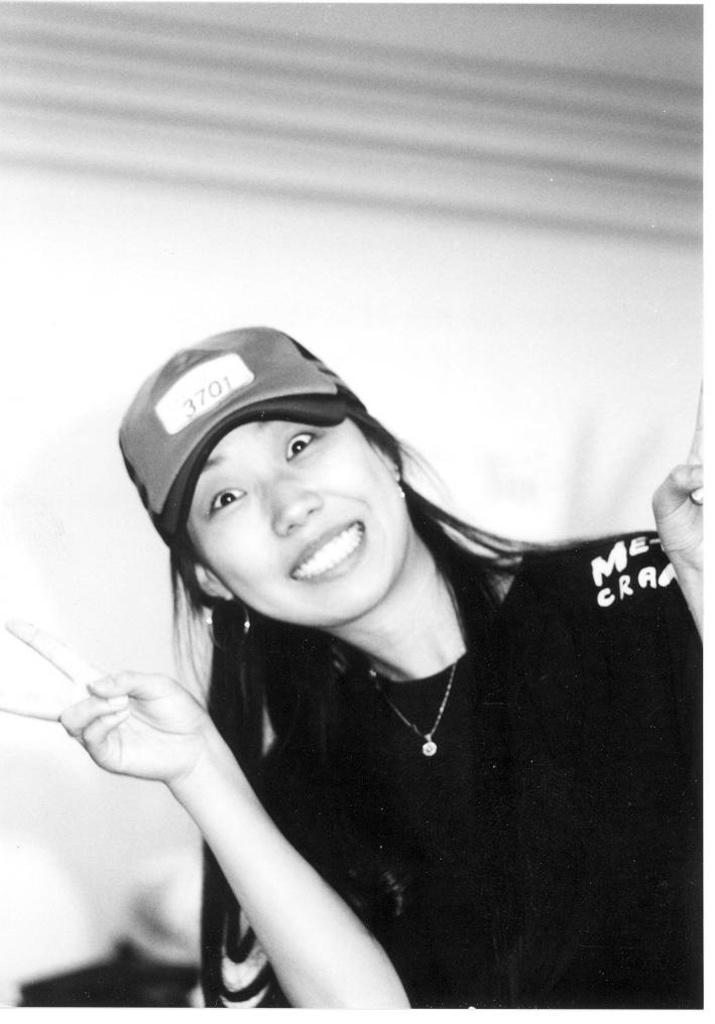What is the color scheme of the image? The image is black and white. Who or what is the main subject in the image? There is a woman in the image. What is the woman wearing on her head? The woman is wearing a cap. What can be seen in the background of the image? There is a wall in the background of the image. How many goats are visible in the image? There are no goats present in the image. What type of jellyfish can be seen swimming in the background of the image? There is no jellyfish present in the image, and the background features a wall. 